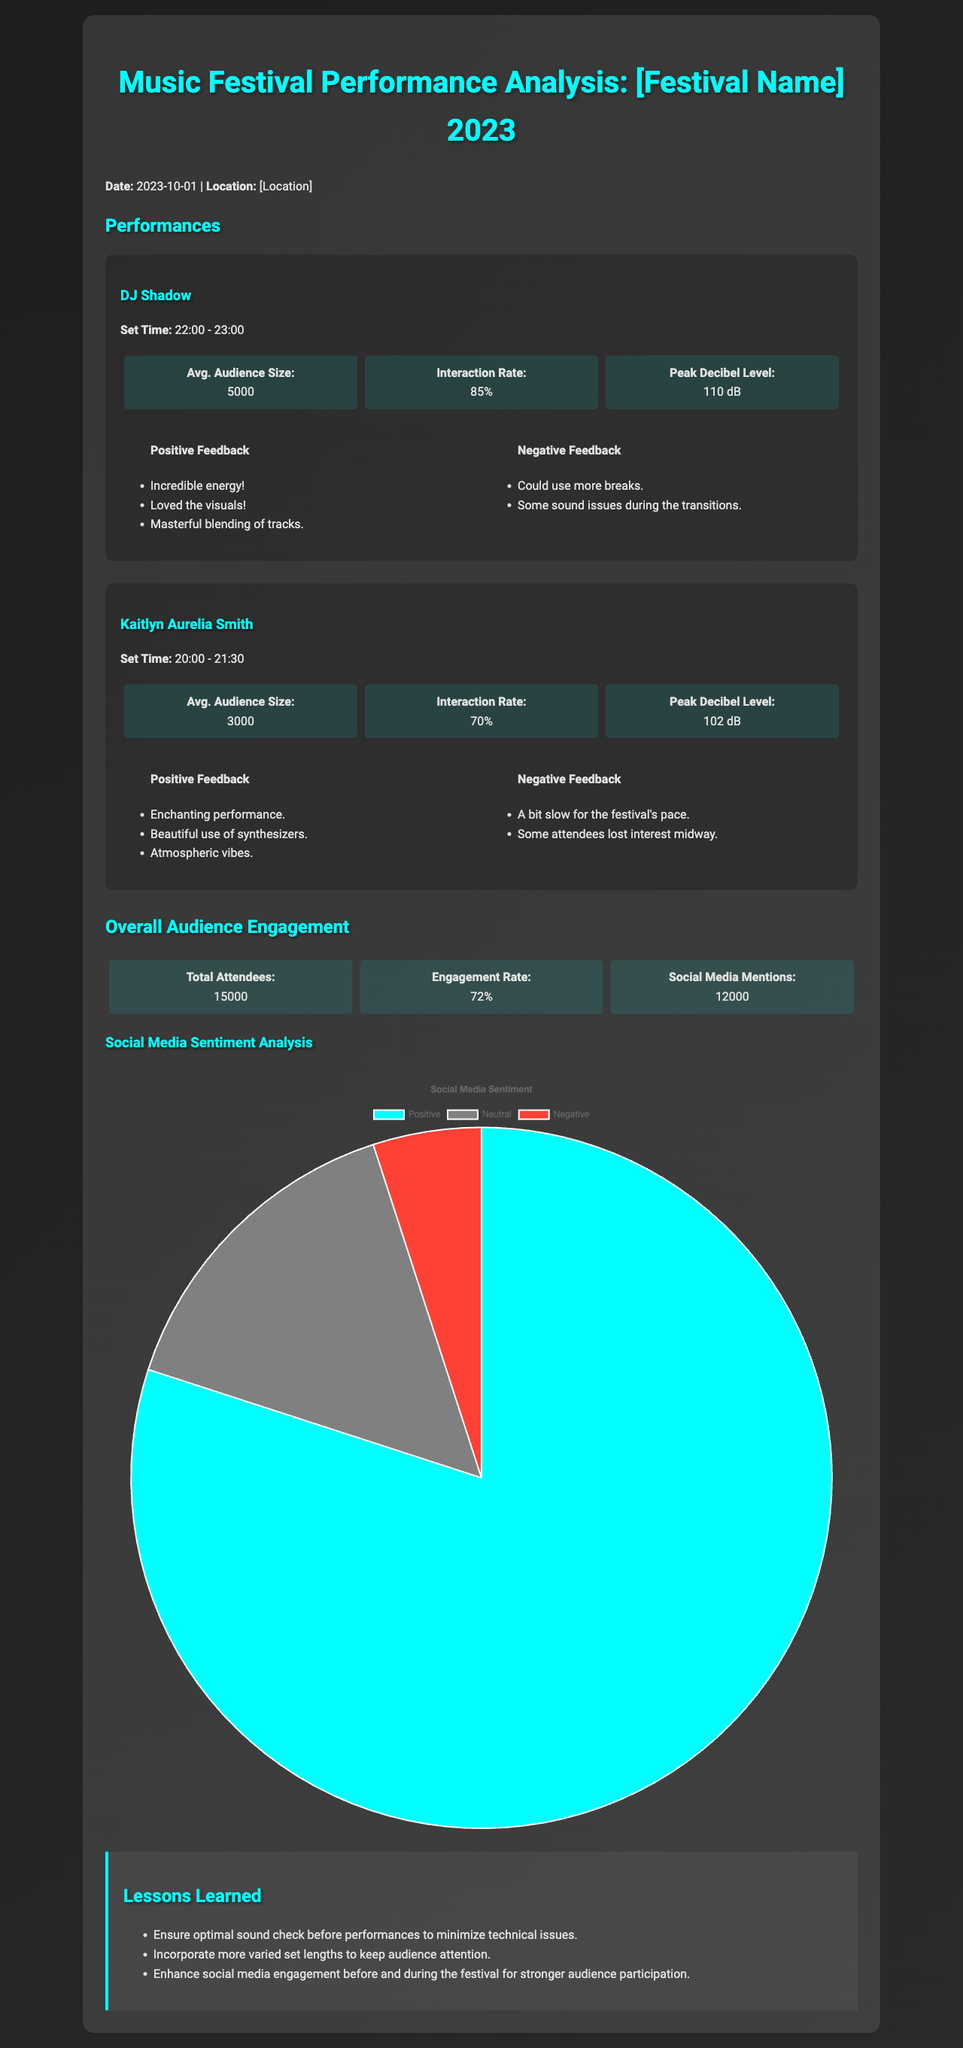What was the date of the festival? The date of the festival is stated clearly in the document's introduction section.
Answer: 2023-10-01 Who performed at the festival at 22:00? The document lists the performers along with their set times, indicating who played at that specific time.
Answer: DJ Shadow What was the average audience size for Kaitlyn Aurelia Smith's performance? The average audience size for each performance is provided under the performance statistics section.
Answer: 3000 What was the interaction rate for DJ Shadow's performance? The interaction rate is indicated in the performance statistics, showing engagement levels for each performer.
Answer: 85% What percentage of social media sentiment was positive? The document includes a pie chart summarizing social media sentiment analysis, specifically showing positive, neutral, and negative sentiments.
Answer: 80% How many total attendees were present at the festival? The total number of attendees is noted in the overall audience engagement section.
Answer: 15000 What lesson was learned about sound checks? The lessons learned are clearly outlined in a section dedicated to recommendations for future events.
Answer: Ensure optimal sound check before performances to minimize technical issues What is the peak decibel level for Kaitlyn Aurelia Smith's performance? The peak decibel level for each performance is provided in the statistics for that performance.
Answer: 102 dB How many social media mentions were there? The number of social media mentions can be found in the overall audience engagement metrics provided in the document.
Answer: 12000 